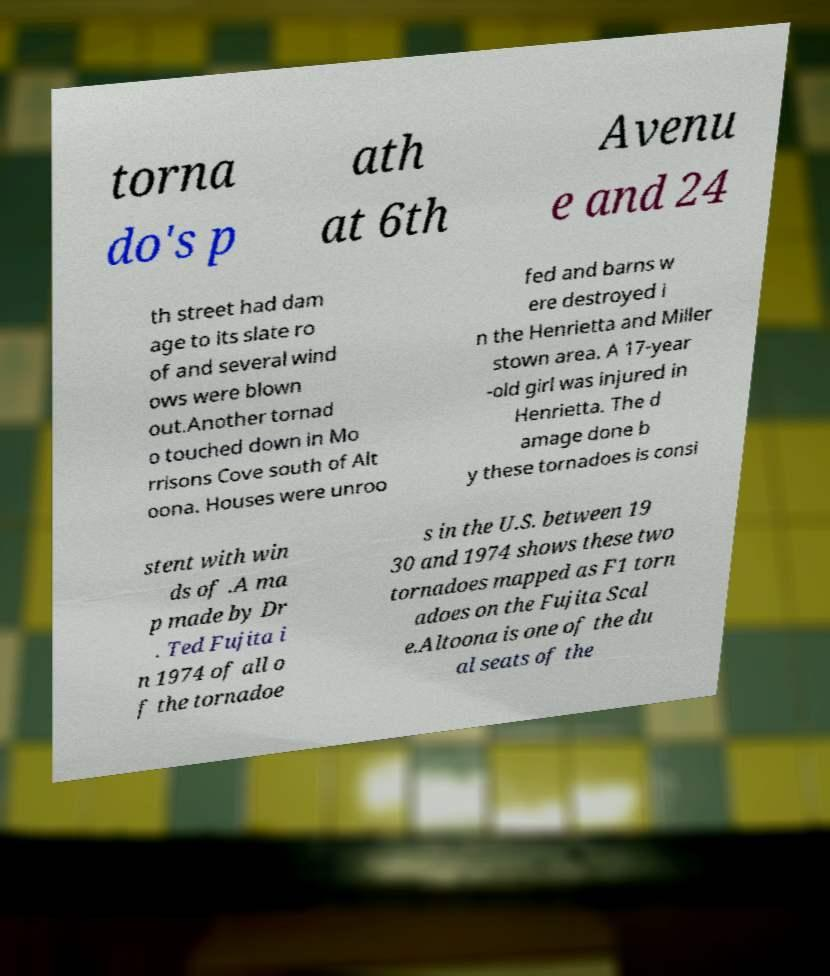What messages or text are displayed in this image? I need them in a readable, typed format. torna do's p ath at 6th Avenu e and 24 th street had dam age to its slate ro of and several wind ows were blown out.Another tornad o touched down in Mo rrisons Cove south of Alt oona. Houses were unroo fed and barns w ere destroyed i n the Henrietta and Miller stown area. A 17-year -old girl was injured in Henrietta. The d amage done b y these tornadoes is consi stent with win ds of .A ma p made by Dr . Ted Fujita i n 1974 of all o f the tornadoe s in the U.S. between 19 30 and 1974 shows these two tornadoes mapped as F1 torn adoes on the Fujita Scal e.Altoona is one of the du al seats of the 